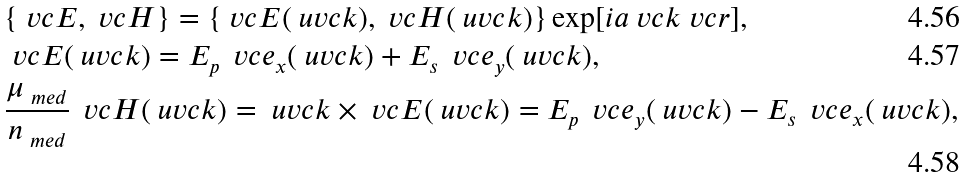<formula> <loc_0><loc_0><loc_500><loc_500>& \{ \ v c { E } , \ v c { H } \} = \{ \ v c { E } ( \ u v c { k } ) , \ v c { H } ( \ u v c { k } ) \} \exp [ i a { \ v c { k } } { \ v c { r } } ] , \\ & \ v c { E } ( \ u v c { k } ) = E _ { p } \, \ v c { e } _ { x } ( \ u v c { k } ) + E _ { s } \, \ v c { e } _ { y } ( \ u v c { k } ) , \\ & \frac { \mu _ { \ m e d } } { n _ { \ m e d } } \, \ v c { H } ( \ u v c { k } ) = \ u v c { k } \times \ v c { E } ( \ u v c { k } ) = E _ { p } \, \ v c { e } _ { y } ( \ u v c { k } ) - E _ { s } \, \ v c { e } _ { x } ( \ u v c { k } ) ,</formula> 